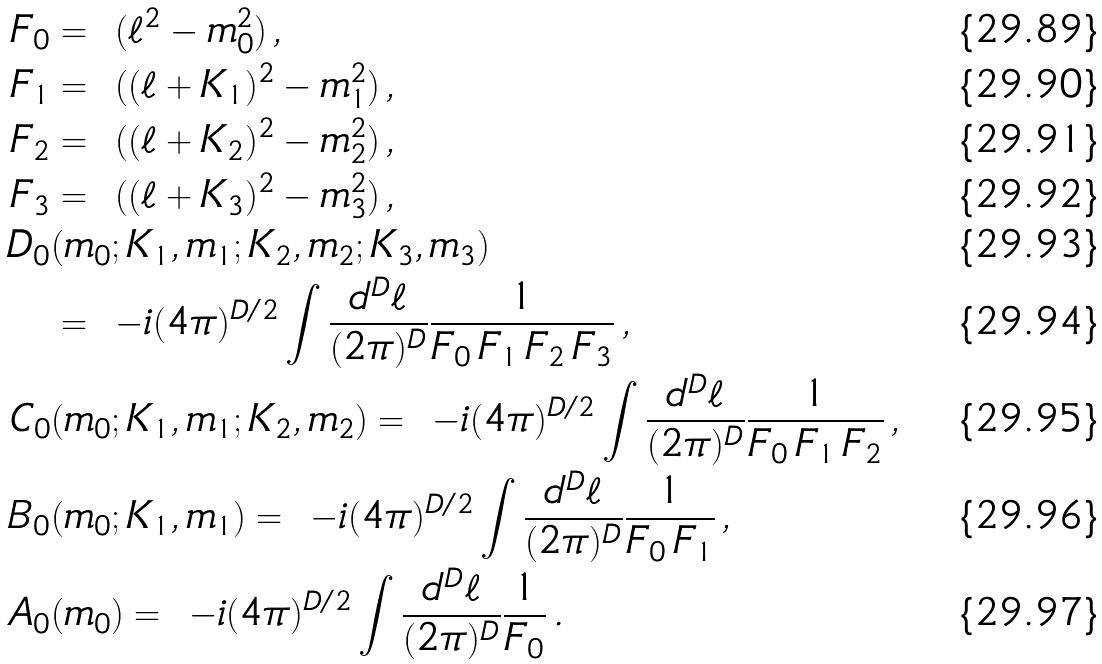Convert formula to latex. <formula><loc_0><loc_0><loc_500><loc_500>F _ { 0 } & = \ ( \ell ^ { 2 } - m _ { 0 } ^ { 2 } ) \, , \\ F _ { 1 } & = \ ( ( \ell + K _ { 1 } ) ^ { 2 } - m _ { 1 } ^ { 2 } ) \, , \\ F _ { 2 } & = \ ( ( \ell + K _ { 2 } ) ^ { 2 } - m _ { 2 } ^ { 2 } ) \, , \\ F _ { 3 } & = \ ( ( \ell + K _ { 3 } ) ^ { 2 } - m _ { 3 } ^ { 2 } ) \, , \\ D _ { 0 } & ( m _ { 0 } ; K _ { 1 } , m _ { 1 } ; K _ { 2 } , m _ { 2 } ; K _ { 3 } , m _ { 3 } ) \\ & = \ - i ( 4 \pi ) ^ { D / 2 } \int \frac { d ^ { D } \ell } { ( 2 \pi ) ^ { D } } \frac { 1 } { F _ { 0 } \, F _ { 1 } \, F _ { 2 } \, F _ { 3 } } \, , \\ C _ { 0 } & ( m _ { 0 } ; K _ { 1 } , m _ { 1 } ; K _ { 2 } , m _ { 2 } ) = \ - i ( 4 \pi ) ^ { D / 2 } \int \frac { d ^ { D } \ell } { ( 2 \pi ) ^ { D } } \frac { 1 } { F _ { 0 } \, F _ { 1 } \, F _ { 2 } } \, , \\ B _ { 0 } & ( m _ { 0 } ; K _ { 1 } , m _ { 1 } ) = \ - i ( 4 \pi ) ^ { D / 2 } \int \frac { d ^ { D } \ell } { ( 2 \pi ) ^ { D } } \frac { 1 } { F _ { 0 } \, F _ { 1 } } \, , \\ A _ { 0 } & ( m _ { 0 } ) = \ - i ( 4 \pi ) ^ { D / 2 } \int \frac { d ^ { D } \ell } { ( 2 \pi ) ^ { D } } \frac { 1 } { F _ { 0 } } \, .</formula> 